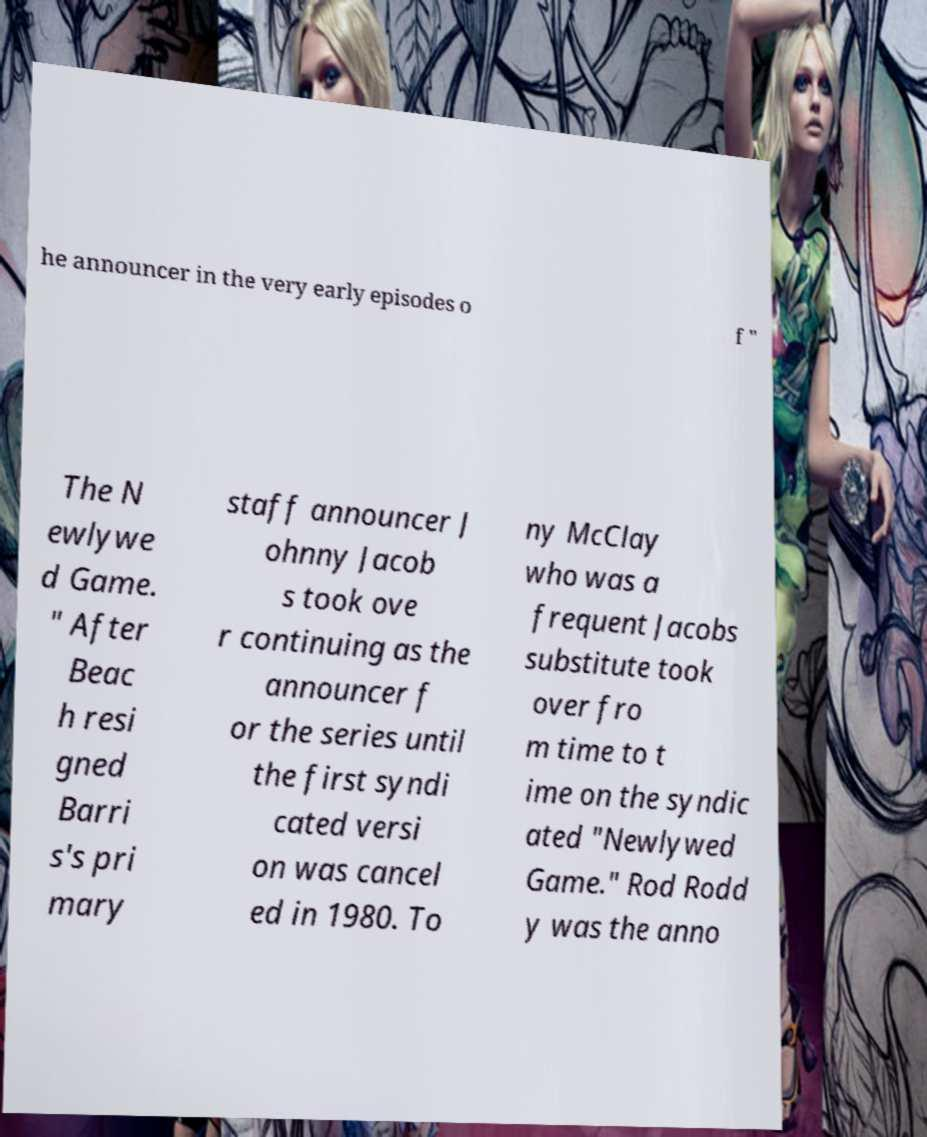What messages or text are displayed in this image? I need them in a readable, typed format. he announcer in the very early episodes o f " The N ewlywe d Game. " After Beac h resi gned Barri s's pri mary staff announcer J ohnny Jacob s took ove r continuing as the announcer f or the series until the first syndi cated versi on was cancel ed in 1980. To ny McClay who was a frequent Jacobs substitute took over fro m time to t ime on the syndic ated "Newlywed Game." Rod Rodd y was the anno 